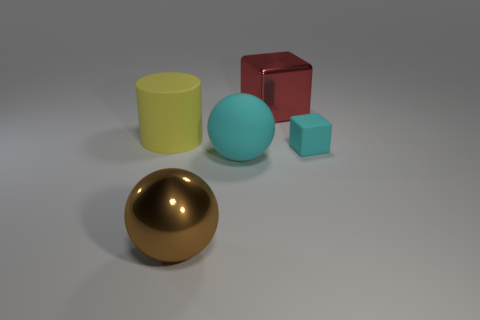Add 3 gray matte cylinders. How many objects exist? 8 Subtract all balls. How many objects are left? 3 Add 3 big brown things. How many big brown things exist? 4 Subtract 0 brown blocks. How many objects are left? 5 Subtract all big cylinders. Subtract all matte balls. How many objects are left? 3 Add 5 large red cubes. How many large red cubes are left? 6 